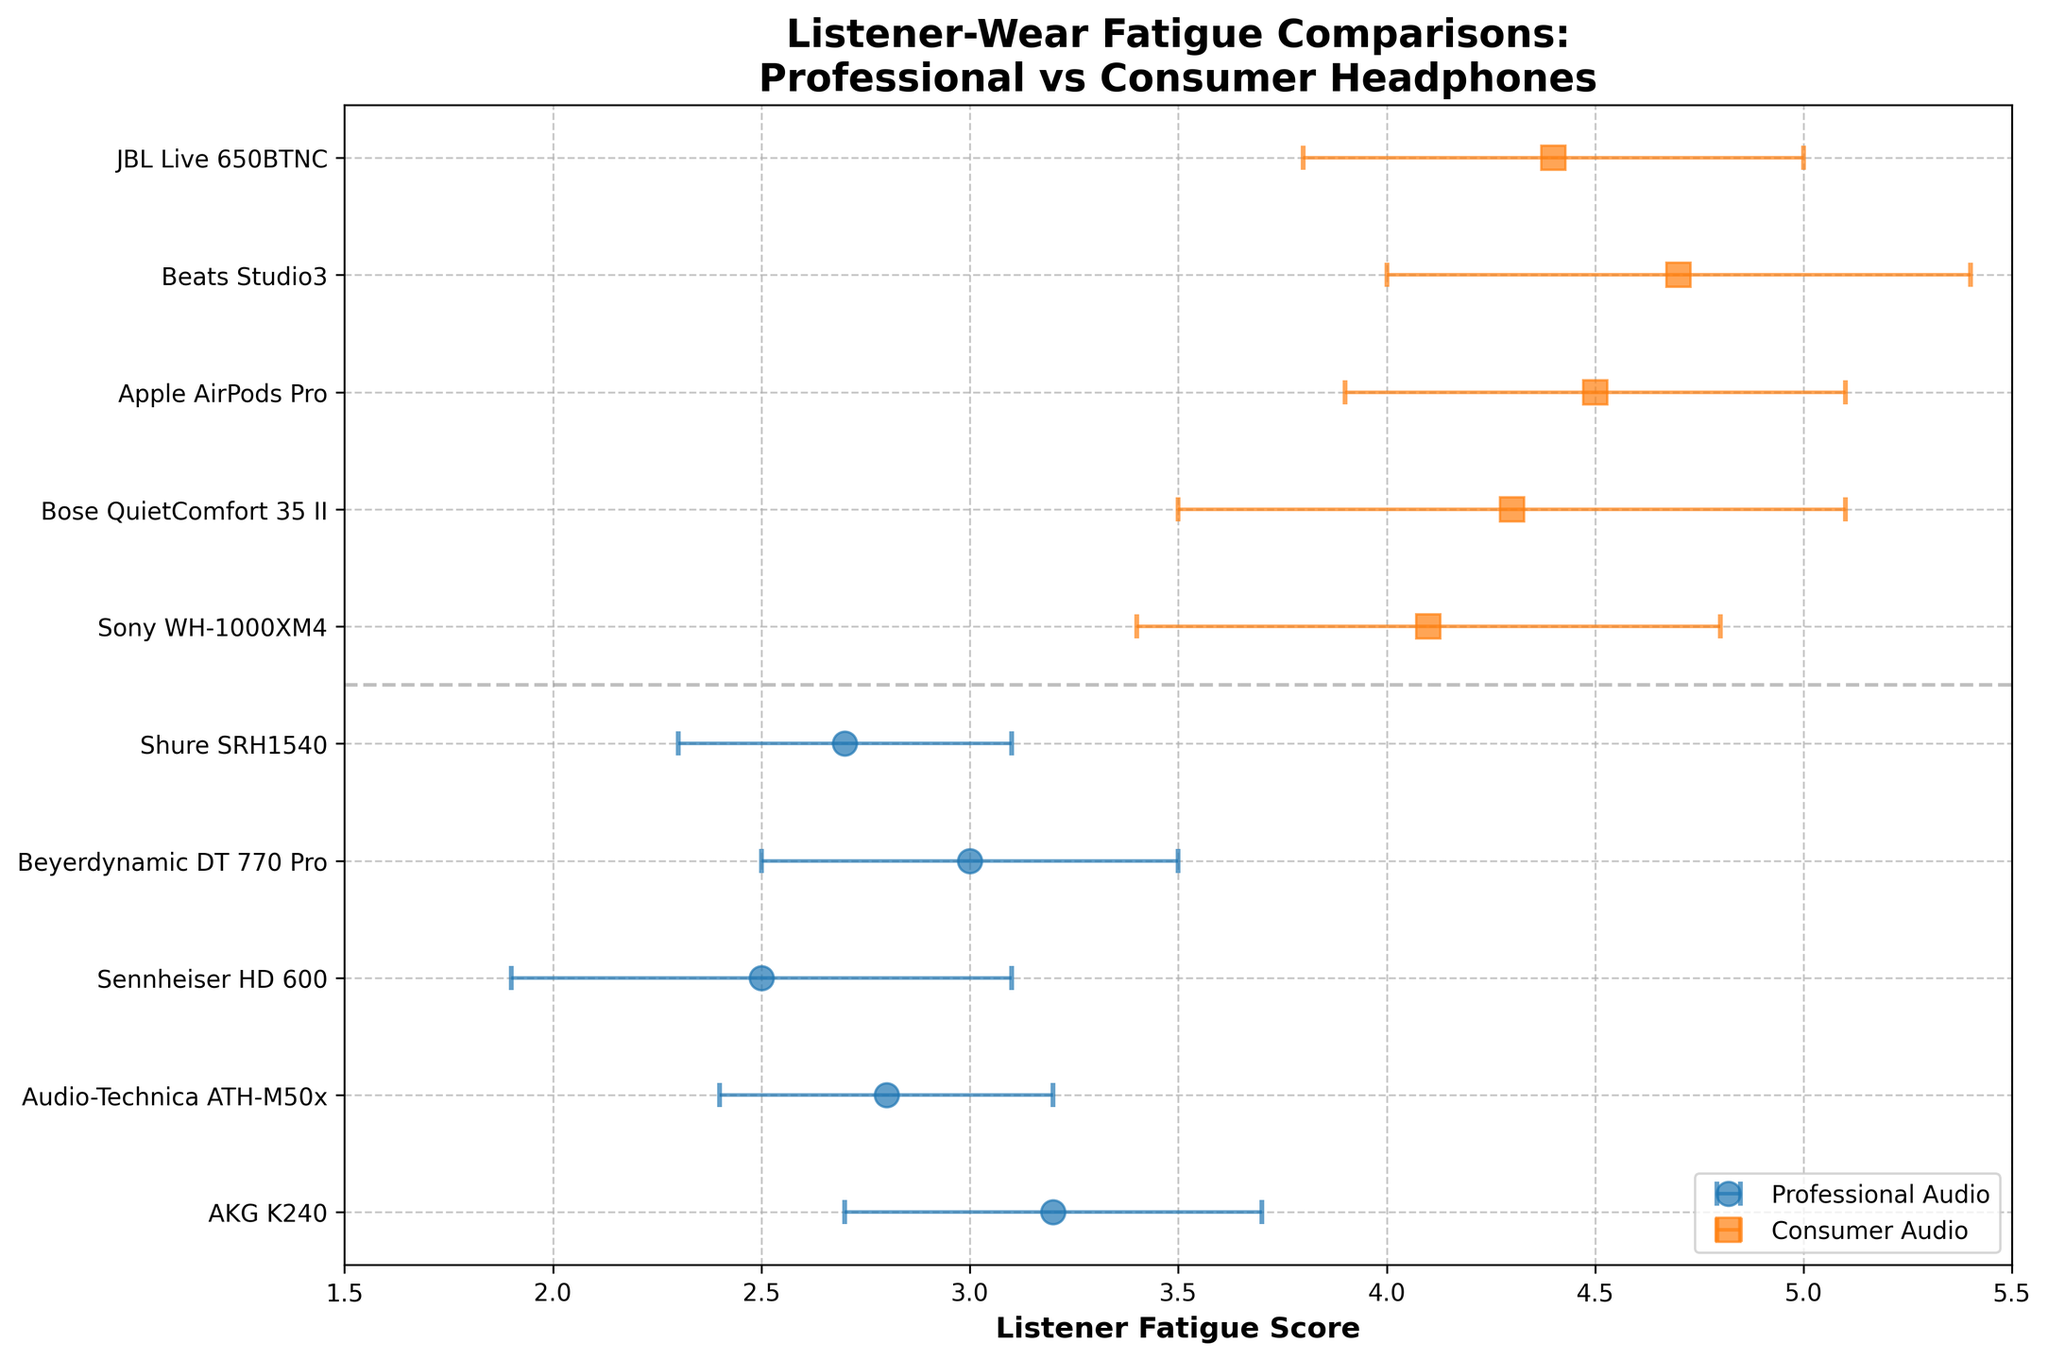What is the Listener Fatigue Score of the Beats Studio3 headphones? The Beats Studio3 headphones are plotted in the Consumer Audio section with an orange square marker. The value corresponding to Beats Studio3 is 4.7 on the x-axis.
Answer: 4.7 Which type of headphones (Professional or Consumer) generally has higher Listener Fatigue Scores? By observing the plot, Consumer Audio headphones (orange squares) have higher Listener Fatigue Scores compared to Professional Audio headphones (blue circles).
Answer: Consumer What is the average Listener Fatigue Score for the Professional Audio headphones? To find the average, add the Listener Fatigue Scores of Professional Audio headphones (3.2 + 2.8 + 2.5 + 3.0 + 2.7) and divide by the number of headphones (5). The sum is 14.2, and the average is 14.2 / 5.
Answer: 2.84 Which Professional Audio headphone has the lowest Listener Fatigue Score? Among Professional Audio headphones, the Sennheiser HD 600 has the lowest score, which is 2.5.
Answer: Sennheiser HD 600 What is the error range for the Sony WH-1000XM4 headphones? The Listener Fatigue Score for the Sony WH-1000XM4 is 4.1 with an error bar of ±0.7. Therefore, the range is from 3.4 to 4.8.
Answer: 3.4 to 4.8 Which has the higher Listener Fatigue Score: Shure SRH1540 or Bose QuietComfort 35 II? Comparing the Listener Fatigue Scores, Shure SRH1540 (2.7) is less than Bose QuietComfort 35 II (4.3).
Answer: Bose QuietComfort 35 II What does the horizontal dashed line signify in the plot? The horizontal dashed line separates the Professional and Consumer audio headphone sections. It is placed between the ranges at the index separating the two headphone types.
Answer: Separation between headphone types Which Consumer Audio headphone has the smallest error bar? By comparing the error bars of Consumer Audio headphones, the Apple AirPods Pro shows the smallest error bar of ±0.6.
Answer: Apple AirPods Pro What is the total range of Listener Fatigue Scores observed in the plot? The lowest Listener Fatigue Score is 2.5 (Sennheiser HD 600), and the highest is 4.7 (Beats Studio3). Thus, the range is 4.7 - 2.5.
Answer: 2.2 